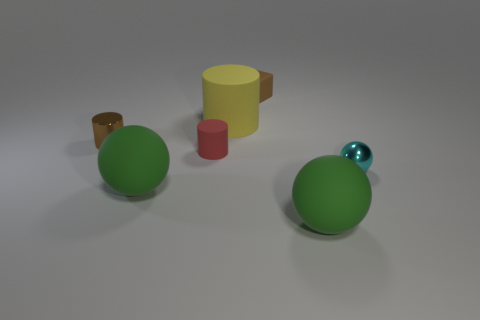How many rubber things are either small yellow cubes or large green balls?
Keep it short and to the point. 2. Are there any brown cylinders in front of the matte ball that is on the right side of the cylinder that is behind the brown cylinder?
Make the answer very short. No. The brown object that is the same material as the red cylinder is what size?
Offer a very short reply. Small. There is a tiny brown shiny thing; are there any brown metallic objects left of it?
Provide a short and direct response. No. There is a small brown cylinder in front of the tiny matte cube; is there a small brown metallic thing on the right side of it?
Offer a terse response. No. There is a matte ball to the right of the large yellow cylinder; does it have the same size as the rubber cylinder to the left of the yellow cylinder?
Give a very brief answer. No. How many small objects are red things or cyan metal spheres?
Provide a short and direct response. 2. The small brown thing in front of the brown object behind the large yellow rubber cylinder is made of what material?
Make the answer very short. Metal. What is the shape of the small metal object that is the same color as the block?
Make the answer very short. Cylinder. Is there a cube that has the same material as the large yellow thing?
Make the answer very short. Yes. 